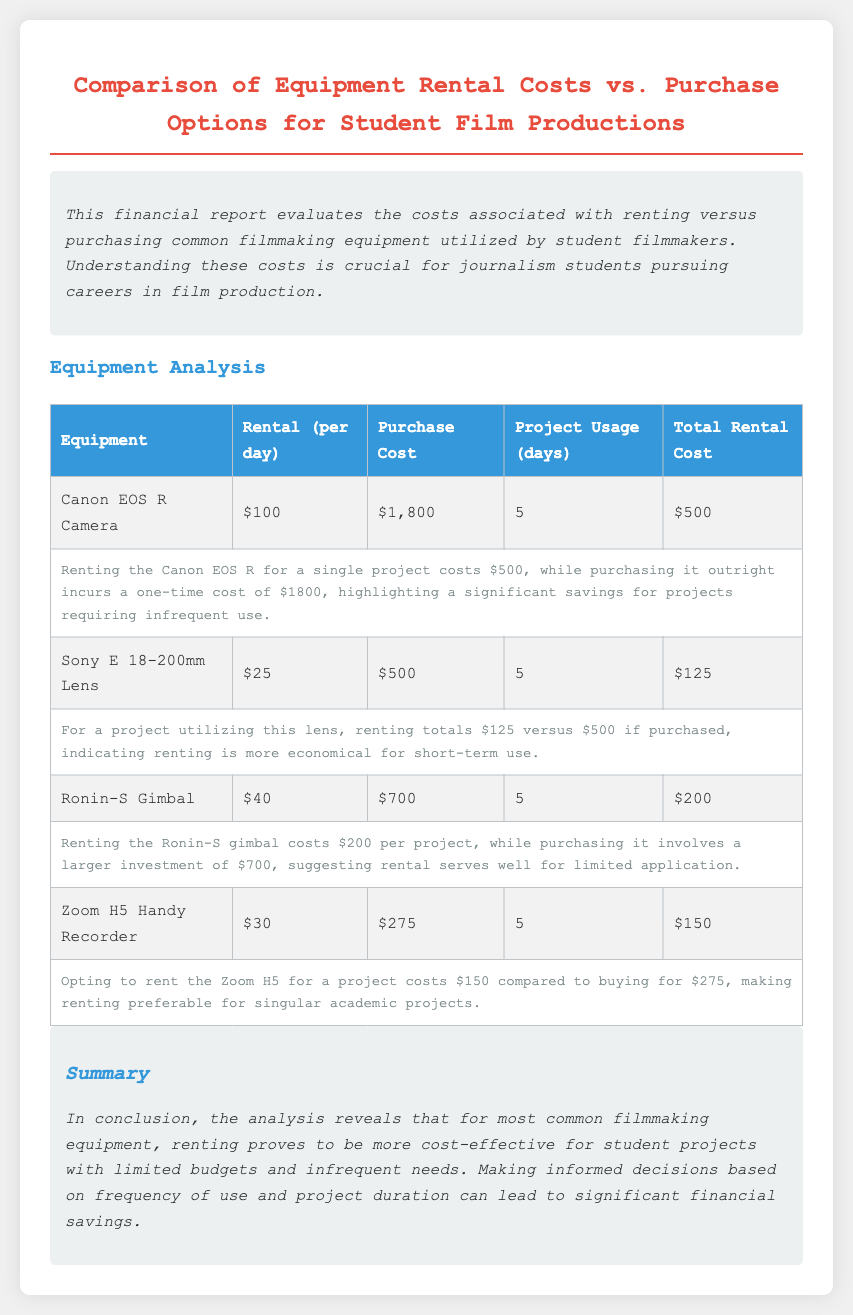What is the rental cost per day for a Canon EOS R Camera? The rental cost per day for a Canon EOS R Camera is stated in the table.
Answer: $100 What is the purchase cost of the Sony E 18-200mm Lens? The purchase cost is clearly listed in the equipment analysis table.
Answer: $500 How many days is the Canon EOS R Camera projected to be used? This information can be found in the "Project Usage (days)" column of the table.
Answer: 5 What is the total rental cost for the Ronin-S Gimbal? The document specifies the total rental cost for the Ronin-S Gimbal based on usage in the table.
Answer: $200 Which equipment has a lower rental cost compared to its purchase cost? This question pertains to the analysis provided for the equipment listed in the document.
Answer: All listed equipment What is the purchase cost of the Zoom H5 Handy Recorder? The purchase cost is specifically stated in the table under its respective column.
Answer: $275 What is the conclusion regarding renting vs. purchasing equipment? The summary presents an overall evaluation based on the provided data.
Answer: Renting is more cost-effective How many pieces of equipment are analyzed in the report? The number of equipment listed can be counted from the "Equipment Analysis" table.
Answer: Four What color is the heading of the document? The header colors are mentioned in the style section of the document.
Answer: Red What is the primary purpose of this financial report? The introductory section provides insight into the goals of the report.
Answer: To evaluate equipment costs 